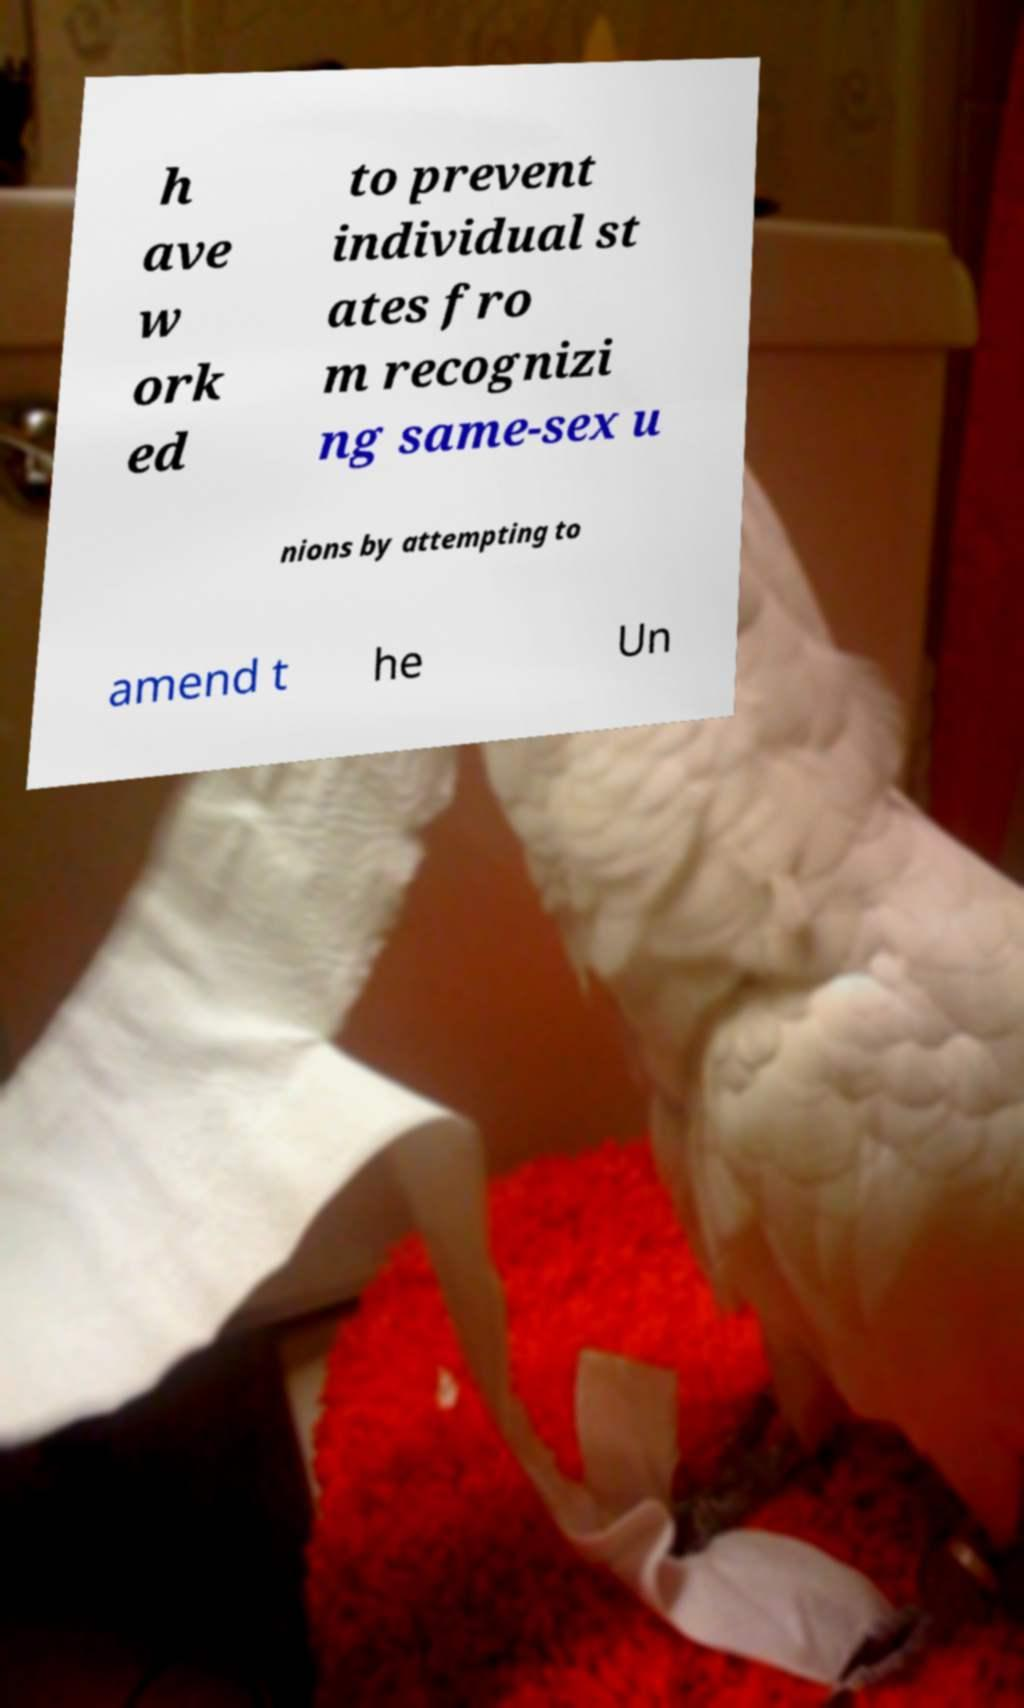I need the written content from this picture converted into text. Can you do that? h ave w ork ed to prevent individual st ates fro m recognizi ng same-sex u nions by attempting to amend t he Un 